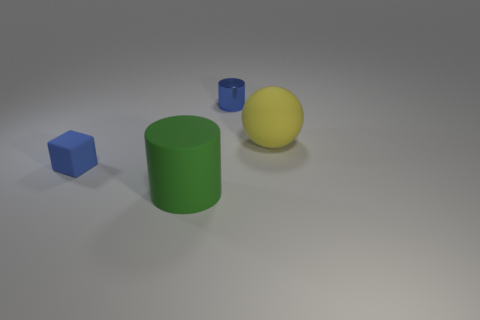There is a tiny thing that is behind the rubber block; is it the same color as the tiny block?
Your response must be concise. Yes. How many large things are there?
Your response must be concise. 2. There is a matte object that is on the right side of the tiny cube and on the left side of the big yellow matte ball; what is its color?
Provide a succinct answer. Green. What size is the blue metal object that is the same shape as the green matte object?
Make the answer very short. Small. What number of yellow things have the same size as the green rubber object?
Offer a terse response. 1. What material is the big green thing?
Provide a short and direct response. Rubber. There is a yellow object; are there any big rubber cylinders in front of it?
Ensure brevity in your answer.  Yes. What is the size of the blue cube that is made of the same material as the yellow object?
Offer a terse response. Small. How many other things are the same color as the metallic object?
Your answer should be very brief. 1. Are there fewer big green rubber things that are behind the tiny blue metallic cylinder than tiny metal cylinders that are on the right side of the large green matte thing?
Your response must be concise. Yes. 